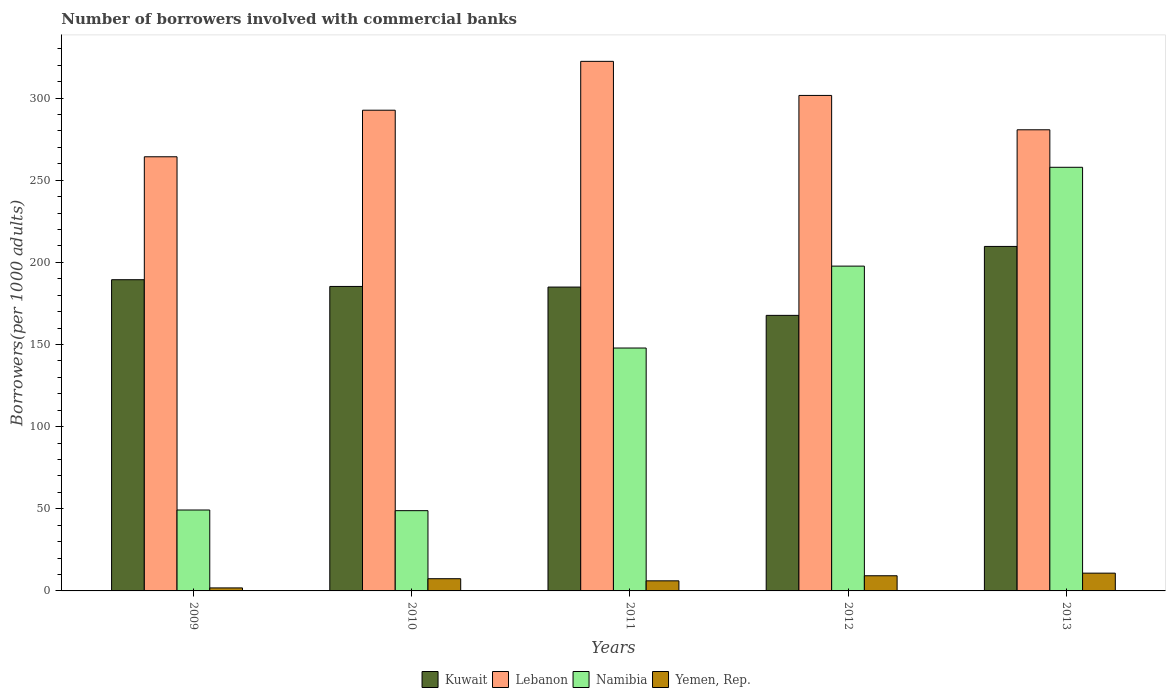How many different coloured bars are there?
Offer a terse response. 4. How many groups of bars are there?
Your answer should be very brief. 5. Are the number of bars per tick equal to the number of legend labels?
Provide a succinct answer. Yes. Are the number of bars on each tick of the X-axis equal?
Your response must be concise. Yes. What is the number of borrowers involved with commercial banks in Lebanon in 2010?
Provide a succinct answer. 292.58. Across all years, what is the maximum number of borrowers involved with commercial banks in Yemen, Rep.?
Your response must be concise. 10.82. Across all years, what is the minimum number of borrowers involved with commercial banks in Kuwait?
Your answer should be very brief. 167.71. In which year was the number of borrowers involved with commercial banks in Namibia maximum?
Your answer should be compact. 2013. In which year was the number of borrowers involved with commercial banks in Kuwait minimum?
Offer a very short reply. 2012. What is the total number of borrowers involved with commercial banks in Kuwait in the graph?
Ensure brevity in your answer.  937.07. What is the difference between the number of borrowers involved with commercial banks in Kuwait in 2009 and that in 2013?
Your response must be concise. -20.26. What is the difference between the number of borrowers involved with commercial banks in Kuwait in 2011 and the number of borrowers involved with commercial banks in Lebanon in 2009?
Offer a terse response. -79.3. What is the average number of borrowers involved with commercial banks in Lebanon per year?
Make the answer very short. 292.28. In the year 2010, what is the difference between the number of borrowers involved with commercial banks in Kuwait and number of borrowers involved with commercial banks in Yemen, Rep.?
Keep it short and to the point. 177.89. What is the ratio of the number of borrowers involved with commercial banks in Kuwait in 2009 to that in 2010?
Your response must be concise. 1.02. Is the difference between the number of borrowers involved with commercial banks in Kuwait in 2009 and 2010 greater than the difference between the number of borrowers involved with commercial banks in Yemen, Rep. in 2009 and 2010?
Your answer should be very brief. Yes. What is the difference between the highest and the second highest number of borrowers involved with commercial banks in Lebanon?
Ensure brevity in your answer.  20.74. What is the difference between the highest and the lowest number of borrowers involved with commercial banks in Kuwait?
Your answer should be very brief. 41.96. In how many years, is the number of borrowers involved with commercial banks in Yemen, Rep. greater than the average number of borrowers involved with commercial banks in Yemen, Rep. taken over all years?
Keep it short and to the point. 3. What does the 1st bar from the left in 2009 represents?
Ensure brevity in your answer.  Kuwait. What does the 3rd bar from the right in 2012 represents?
Keep it short and to the point. Lebanon. Are all the bars in the graph horizontal?
Your response must be concise. No. Where does the legend appear in the graph?
Offer a very short reply. Bottom center. What is the title of the graph?
Your answer should be compact. Number of borrowers involved with commercial banks. Does "Romania" appear as one of the legend labels in the graph?
Make the answer very short. No. What is the label or title of the X-axis?
Ensure brevity in your answer.  Years. What is the label or title of the Y-axis?
Offer a very short reply. Borrowers(per 1000 adults). What is the Borrowers(per 1000 adults) in Kuwait in 2009?
Provide a succinct answer. 189.42. What is the Borrowers(per 1000 adults) in Lebanon in 2009?
Ensure brevity in your answer.  264.25. What is the Borrowers(per 1000 adults) in Namibia in 2009?
Your answer should be very brief. 49.25. What is the Borrowers(per 1000 adults) of Yemen, Rep. in 2009?
Your answer should be very brief. 1.83. What is the Borrowers(per 1000 adults) of Kuwait in 2010?
Your response must be concise. 185.32. What is the Borrowers(per 1000 adults) of Lebanon in 2010?
Offer a very short reply. 292.58. What is the Borrowers(per 1000 adults) of Namibia in 2010?
Your answer should be compact. 48.85. What is the Borrowers(per 1000 adults) in Yemen, Rep. in 2010?
Your response must be concise. 7.43. What is the Borrowers(per 1000 adults) in Kuwait in 2011?
Offer a very short reply. 184.94. What is the Borrowers(per 1000 adults) of Lebanon in 2011?
Provide a succinct answer. 322.32. What is the Borrowers(per 1000 adults) of Namibia in 2011?
Ensure brevity in your answer.  147.84. What is the Borrowers(per 1000 adults) in Yemen, Rep. in 2011?
Offer a very short reply. 6.14. What is the Borrowers(per 1000 adults) of Kuwait in 2012?
Give a very brief answer. 167.71. What is the Borrowers(per 1000 adults) in Lebanon in 2012?
Offer a very short reply. 301.58. What is the Borrowers(per 1000 adults) in Namibia in 2012?
Provide a short and direct response. 197.69. What is the Borrowers(per 1000 adults) in Yemen, Rep. in 2012?
Your answer should be very brief. 9.23. What is the Borrowers(per 1000 adults) of Kuwait in 2013?
Keep it short and to the point. 209.68. What is the Borrowers(per 1000 adults) of Lebanon in 2013?
Offer a very short reply. 280.67. What is the Borrowers(per 1000 adults) of Namibia in 2013?
Your answer should be compact. 257.84. What is the Borrowers(per 1000 adults) in Yemen, Rep. in 2013?
Make the answer very short. 10.82. Across all years, what is the maximum Borrowers(per 1000 adults) of Kuwait?
Your response must be concise. 209.68. Across all years, what is the maximum Borrowers(per 1000 adults) of Lebanon?
Offer a very short reply. 322.32. Across all years, what is the maximum Borrowers(per 1000 adults) of Namibia?
Make the answer very short. 257.84. Across all years, what is the maximum Borrowers(per 1000 adults) in Yemen, Rep.?
Your response must be concise. 10.82. Across all years, what is the minimum Borrowers(per 1000 adults) of Kuwait?
Your answer should be compact. 167.71. Across all years, what is the minimum Borrowers(per 1000 adults) in Lebanon?
Your response must be concise. 264.25. Across all years, what is the minimum Borrowers(per 1000 adults) of Namibia?
Keep it short and to the point. 48.85. Across all years, what is the minimum Borrowers(per 1000 adults) of Yemen, Rep.?
Give a very brief answer. 1.83. What is the total Borrowers(per 1000 adults) in Kuwait in the graph?
Your answer should be very brief. 937.07. What is the total Borrowers(per 1000 adults) of Lebanon in the graph?
Provide a succinct answer. 1461.39. What is the total Borrowers(per 1000 adults) of Namibia in the graph?
Give a very brief answer. 701.47. What is the total Borrowers(per 1000 adults) of Yemen, Rep. in the graph?
Your answer should be compact. 35.45. What is the difference between the Borrowers(per 1000 adults) in Kuwait in 2009 and that in 2010?
Give a very brief answer. 4.09. What is the difference between the Borrowers(per 1000 adults) of Lebanon in 2009 and that in 2010?
Ensure brevity in your answer.  -28.33. What is the difference between the Borrowers(per 1000 adults) in Namibia in 2009 and that in 2010?
Offer a terse response. 0.4. What is the difference between the Borrowers(per 1000 adults) in Yemen, Rep. in 2009 and that in 2010?
Give a very brief answer. -5.6. What is the difference between the Borrowers(per 1000 adults) in Kuwait in 2009 and that in 2011?
Your response must be concise. 4.47. What is the difference between the Borrowers(per 1000 adults) in Lebanon in 2009 and that in 2011?
Your answer should be compact. -58.07. What is the difference between the Borrowers(per 1000 adults) in Namibia in 2009 and that in 2011?
Keep it short and to the point. -98.59. What is the difference between the Borrowers(per 1000 adults) in Yemen, Rep. in 2009 and that in 2011?
Your response must be concise. -4.32. What is the difference between the Borrowers(per 1000 adults) in Kuwait in 2009 and that in 2012?
Keep it short and to the point. 21.7. What is the difference between the Borrowers(per 1000 adults) in Lebanon in 2009 and that in 2012?
Provide a short and direct response. -37.33. What is the difference between the Borrowers(per 1000 adults) in Namibia in 2009 and that in 2012?
Make the answer very short. -148.44. What is the difference between the Borrowers(per 1000 adults) in Yemen, Rep. in 2009 and that in 2012?
Your answer should be compact. -7.41. What is the difference between the Borrowers(per 1000 adults) in Kuwait in 2009 and that in 2013?
Your answer should be very brief. -20.26. What is the difference between the Borrowers(per 1000 adults) in Lebanon in 2009 and that in 2013?
Make the answer very short. -16.42. What is the difference between the Borrowers(per 1000 adults) of Namibia in 2009 and that in 2013?
Your answer should be very brief. -208.59. What is the difference between the Borrowers(per 1000 adults) of Yemen, Rep. in 2009 and that in 2013?
Offer a very short reply. -8.99. What is the difference between the Borrowers(per 1000 adults) in Kuwait in 2010 and that in 2011?
Your response must be concise. 0.38. What is the difference between the Borrowers(per 1000 adults) in Lebanon in 2010 and that in 2011?
Provide a succinct answer. -29.74. What is the difference between the Borrowers(per 1000 adults) of Namibia in 2010 and that in 2011?
Offer a very short reply. -99. What is the difference between the Borrowers(per 1000 adults) of Yemen, Rep. in 2010 and that in 2011?
Provide a succinct answer. 1.29. What is the difference between the Borrowers(per 1000 adults) in Kuwait in 2010 and that in 2012?
Your answer should be very brief. 17.61. What is the difference between the Borrowers(per 1000 adults) of Lebanon in 2010 and that in 2012?
Give a very brief answer. -9. What is the difference between the Borrowers(per 1000 adults) of Namibia in 2010 and that in 2012?
Provide a short and direct response. -148.84. What is the difference between the Borrowers(per 1000 adults) of Yemen, Rep. in 2010 and that in 2012?
Keep it short and to the point. -1.8. What is the difference between the Borrowers(per 1000 adults) of Kuwait in 2010 and that in 2013?
Your answer should be compact. -24.35. What is the difference between the Borrowers(per 1000 adults) of Lebanon in 2010 and that in 2013?
Provide a short and direct response. 11.91. What is the difference between the Borrowers(per 1000 adults) in Namibia in 2010 and that in 2013?
Ensure brevity in your answer.  -208.99. What is the difference between the Borrowers(per 1000 adults) in Yemen, Rep. in 2010 and that in 2013?
Provide a succinct answer. -3.39. What is the difference between the Borrowers(per 1000 adults) of Kuwait in 2011 and that in 2012?
Your answer should be very brief. 17.23. What is the difference between the Borrowers(per 1000 adults) in Lebanon in 2011 and that in 2012?
Ensure brevity in your answer.  20.74. What is the difference between the Borrowers(per 1000 adults) in Namibia in 2011 and that in 2012?
Give a very brief answer. -49.85. What is the difference between the Borrowers(per 1000 adults) in Yemen, Rep. in 2011 and that in 2012?
Your answer should be compact. -3.09. What is the difference between the Borrowers(per 1000 adults) of Kuwait in 2011 and that in 2013?
Offer a terse response. -24.73. What is the difference between the Borrowers(per 1000 adults) of Lebanon in 2011 and that in 2013?
Make the answer very short. 41.65. What is the difference between the Borrowers(per 1000 adults) in Namibia in 2011 and that in 2013?
Your response must be concise. -110. What is the difference between the Borrowers(per 1000 adults) of Yemen, Rep. in 2011 and that in 2013?
Offer a terse response. -4.67. What is the difference between the Borrowers(per 1000 adults) in Kuwait in 2012 and that in 2013?
Ensure brevity in your answer.  -41.96. What is the difference between the Borrowers(per 1000 adults) of Lebanon in 2012 and that in 2013?
Your answer should be very brief. 20.91. What is the difference between the Borrowers(per 1000 adults) of Namibia in 2012 and that in 2013?
Your answer should be compact. -60.15. What is the difference between the Borrowers(per 1000 adults) in Yemen, Rep. in 2012 and that in 2013?
Your response must be concise. -1.58. What is the difference between the Borrowers(per 1000 adults) in Kuwait in 2009 and the Borrowers(per 1000 adults) in Lebanon in 2010?
Ensure brevity in your answer.  -103.17. What is the difference between the Borrowers(per 1000 adults) in Kuwait in 2009 and the Borrowers(per 1000 adults) in Namibia in 2010?
Provide a succinct answer. 140.57. What is the difference between the Borrowers(per 1000 adults) of Kuwait in 2009 and the Borrowers(per 1000 adults) of Yemen, Rep. in 2010?
Give a very brief answer. 181.99. What is the difference between the Borrowers(per 1000 adults) in Lebanon in 2009 and the Borrowers(per 1000 adults) in Namibia in 2010?
Provide a short and direct response. 215.4. What is the difference between the Borrowers(per 1000 adults) in Lebanon in 2009 and the Borrowers(per 1000 adults) in Yemen, Rep. in 2010?
Your answer should be compact. 256.82. What is the difference between the Borrowers(per 1000 adults) in Namibia in 2009 and the Borrowers(per 1000 adults) in Yemen, Rep. in 2010?
Provide a succinct answer. 41.82. What is the difference between the Borrowers(per 1000 adults) in Kuwait in 2009 and the Borrowers(per 1000 adults) in Lebanon in 2011?
Give a very brief answer. -132.9. What is the difference between the Borrowers(per 1000 adults) in Kuwait in 2009 and the Borrowers(per 1000 adults) in Namibia in 2011?
Your answer should be very brief. 41.57. What is the difference between the Borrowers(per 1000 adults) in Kuwait in 2009 and the Borrowers(per 1000 adults) in Yemen, Rep. in 2011?
Your answer should be very brief. 183.27. What is the difference between the Borrowers(per 1000 adults) of Lebanon in 2009 and the Borrowers(per 1000 adults) of Namibia in 2011?
Your answer should be compact. 116.4. What is the difference between the Borrowers(per 1000 adults) in Lebanon in 2009 and the Borrowers(per 1000 adults) in Yemen, Rep. in 2011?
Offer a terse response. 258.1. What is the difference between the Borrowers(per 1000 adults) in Namibia in 2009 and the Borrowers(per 1000 adults) in Yemen, Rep. in 2011?
Your answer should be compact. 43.11. What is the difference between the Borrowers(per 1000 adults) in Kuwait in 2009 and the Borrowers(per 1000 adults) in Lebanon in 2012?
Give a very brief answer. -112.16. What is the difference between the Borrowers(per 1000 adults) in Kuwait in 2009 and the Borrowers(per 1000 adults) in Namibia in 2012?
Keep it short and to the point. -8.27. What is the difference between the Borrowers(per 1000 adults) of Kuwait in 2009 and the Borrowers(per 1000 adults) of Yemen, Rep. in 2012?
Provide a short and direct response. 180.18. What is the difference between the Borrowers(per 1000 adults) in Lebanon in 2009 and the Borrowers(per 1000 adults) in Namibia in 2012?
Provide a succinct answer. 66.56. What is the difference between the Borrowers(per 1000 adults) of Lebanon in 2009 and the Borrowers(per 1000 adults) of Yemen, Rep. in 2012?
Your answer should be compact. 255.01. What is the difference between the Borrowers(per 1000 adults) in Namibia in 2009 and the Borrowers(per 1000 adults) in Yemen, Rep. in 2012?
Provide a succinct answer. 40.02. What is the difference between the Borrowers(per 1000 adults) of Kuwait in 2009 and the Borrowers(per 1000 adults) of Lebanon in 2013?
Ensure brevity in your answer.  -91.25. What is the difference between the Borrowers(per 1000 adults) of Kuwait in 2009 and the Borrowers(per 1000 adults) of Namibia in 2013?
Provide a short and direct response. -68.43. What is the difference between the Borrowers(per 1000 adults) in Kuwait in 2009 and the Borrowers(per 1000 adults) in Yemen, Rep. in 2013?
Provide a succinct answer. 178.6. What is the difference between the Borrowers(per 1000 adults) of Lebanon in 2009 and the Borrowers(per 1000 adults) of Namibia in 2013?
Give a very brief answer. 6.41. What is the difference between the Borrowers(per 1000 adults) in Lebanon in 2009 and the Borrowers(per 1000 adults) in Yemen, Rep. in 2013?
Provide a succinct answer. 253.43. What is the difference between the Borrowers(per 1000 adults) in Namibia in 2009 and the Borrowers(per 1000 adults) in Yemen, Rep. in 2013?
Make the answer very short. 38.43. What is the difference between the Borrowers(per 1000 adults) of Kuwait in 2010 and the Borrowers(per 1000 adults) of Lebanon in 2011?
Provide a succinct answer. -137. What is the difference between the Borrowers(per 1000 adults) in Kuwait in 2010 and the Borrowers(per 1000 adults) in Namibia in 2011?
Your answer should be compact. 37.48. What is the difference between the Borrowers(per 1000 adults) of Kuwait in 2010 and the Borrowers(per 1000 adults) of Yemen, Rep. in 2011?
Provide a succinct answer. 179.18. What is the difference between the Borrowers(per 1000 adults) of Lebanon in 2010 and the Borrowers(per 1000 adults) of Namibia in 2011?
Make the answer very short. 144.74. What is the difference between the Borrowers(per 1000 adults) of Lebanon in 2010 and the Borrowers(per 1000 adults) of Yemen, Rep. in 2011?
Offer a very short reply. 286.44. What is the difference between the Borrowers(per 1000 adults) of Namibia in 2010 and the Borrowers(per 1000 adults) of Yemen, Rep. in 2011?
Give a very brief answer. 42.7. What is the difference between the Borrowers(per 1000 adults) of Kuwait in 2010 and the Borrowers(per 1000 adults) of Lebanon in 2012?
Provide a succinct answer. -116.26. What is the difference between the Borrowers(per 1000 adults) in Kuwait in 2010 and the Borrowers(per 1000 adults) in Namibia in 2012?
Offer a very short reply. -12.37. What is the difference between the Borrowers(per 1000 adults) in Kuwait in 2010 and the Borrowers(per 1000 adults) in Yemen, Rep. in 2012?
Offer a very short reply. 176.09. What is the difference between the Borrowers(per 1000 adults) in Lebanon in 2010 and the Borrowers(per 1000 adults) in Namibia in 2012?
Provide a succinct answer. 94.89. What is the difference between the Borrowers(per 1000 adults) in Lebanon in 2010 and the Borrowers(per 1000 adults) in Yemen, Rep. in 2012?
Your response must be concise. 283.35. What is the difference between the Borrowers(per 1000 adults) in Namibia in 2010 and the Borrowers(per 1000 adults) in Yemen, Rep. in 2012?
Offer a very short reply. 39.61. What is the difference between the Borrowers(per 1000 adults) of Kuwait in 2010 and the Borrowers(per 1000 adults) of Lebanon in 2013?
Your answer should be compact. -95.35. What is the difference between the Borrowers(per 1000 adults) in Kuwait in 2010 and the Borrowers(per 1000 adults) in Namibia in 2013?
Provide a succinct answer. -72.52. What is the difference between the Borrowers(per 1000 adults) of Kuwait in 2010 and the Borrowers(per 1000 adults) of Yemen, Rep. in 2013?
Offer a very short reply. 174.5. What is the difference between the Borrowers(per 1000 adults) of Lebanon in 2010 and the Borrowers(per 1000 adults) of Namibia in 2013?
Ensure brevity in your answer.  34.74. What is the difference between the Borrowers(per 1000 adults) in Lebanon in 2010 and the Borrowers(per 1000 adults) in Yemen, Rep. in 2013?
Keep it short and to the point. 281.76. What is the difference between the Borrowers(per 1000 adults) of Namibia in 2010 and the Borrowers(per 1000 adults) of Yemen, Rep. in 2013?
Your answer should be very brief. 38.03. What is the difference between the Borrowers(per 1000 adults) in Kuwait in 2011 and the Borrowers(per 1000 adults) in Lebanon in 2012?
Give a very brief answer. -116.63. What is the difference between the Borrowers(per 1000 adults) of Kuwait in 2011 and the Borrowers(per 1000 adults) of Namibia in 2012?
Your response must be concise. -12.75. What is the difference between the Borrowers(per 1000 adults) of Kuwait in 2011 and the Borrowers(per 1000 adults) of Yemen, Rep. in 2012?
Your answer should be compact. 175.71. What is the difference between the Borrowers(per 1000 adults) of Lebanon in 2011 and the Borrowers(per 1000 adults) of Namibia in 2012?
Give a very brief answer. 124.63. What is the difference between the Borrowers(per 1000 adults) in Lebanon in 2011 and the Borrowers(per 1000 adults) in Yemen, Rep. in 2012?
Your answer should be very brief. 313.09. What is the difference between the Borrowers(per 1000 adults) in Namibia in 2011 and the Borrowers(per 1000 adults) in Yemen, Rep. in 2012?
Your answer should be very brief. 138.61. What is the difference between the Borrowers(per 1000 adults) in Kuwait in 2011 and the Borrowers(per 1000 adults) in Lebanon in 2013?
Provide a short and direct response. -95.72. What is the difference between the Borrowers(per 1000 adults) in Kuwait in 2011 and the Borrowers(per 1000 adults) in Namibia in 2013?
Provide a short and direct response. -72.9. What is the difference between the Borrowers(per 1000 adults) of Kuwait in 2011 and the Borrowers(per 1000 adults) of Yemen, Rep. in 2013?
Give a very brief answer. 174.13. What is the difference between the Borrowers(per 1000 adults) in Lebanon in 2011 and the Borrowers(per 1000 adults) in Namibia in 2013?
Your answer should be very brief. 64.48. What is the difference between the Borrowers(per 1000 adults) in Lebanon in 2011 and the Borrowers(per 1000 adults) in Yemen, Rep. in 2013?
Your answer should be compact. 311.5. What is the difference between the Borrowers(per 1000 adults) in Namibia in 2011 and the Borrowers(per 1000 adults) in Yemen, Rep. in 2013?
Make the answer very short. 137.03. What is the difference between the Borrowers(per 1000 adults) in Kuwait in 2012 and the Borrowers(per 1000 adults) in Lebanon in 2013?
Offer a terse response. -112.95. What is the difference between the Borrowers(per 1000 adults) of Kuwait in 2012 and the Borrowers(per 1000 adults) of Namibia in 2013?
Provide a succinct answer. -90.13. What is the difference between the Borrowers(per 1000 adults) of Kuwait in 2012 and the Borrowers(per 1000 adults) of Yemen, Rep. in 2013?
Offer a terse response. 156.9. What is the difference between the Borrowers(per 1000 adults) in Lebanon in 2012 and the Borrowers(per 1000 adults) in Namibia in 2013?
Your answer should be very brief. 43.74. What is the difference between the Borrowers(per 1000 adults) in Lebanon in 2012 and the Borrowers(per 1000 adults) in Yemen, Rep. in 2013?
Offer a terse response. 290.76. What is the difference between the Borrowers(per 1000 adults) of Namibia in 2012 and the Borrowers(per 1000 adults) of Yemen, Rep. in 2013?
Provide a short and direct response. 186.87. What is the average Borrowers(per 1000 adults) in Kuwait per year?
Give a very brief answer. 187.41. What is the average Borrowers(per 1000 adults) in Lebanon per year?
Keep it short and to the point. 292.28. What is the average Borrowers(per 1000 adults) in Namibia per year?
Your response must be concise. 140.29. What is the average Borrowers(per 1000 adults) of Yemen, Rep. per year?
Provide a succinct answer. 7.09. In the year 2009, what is the difference between the Borrowers(per 1000 adults) of Kuwait and Borrowers(per 1000 adults) of Lebanon?
Your answer should be very brief. -74.83. In the year 2009, what is the difference between the Borrowers(per 1000 adults) of Kuwait and Borrowers(per 1000 adults) of Namibia?
Your answer should be very brief. 140.17. In the year 2009, what is the difference between the Borrowers(per 1000 adults) in Kuwait and Borrowers(per 1000 adults) in Yemen, Rep.?
Your answer should be compact. 187.59. In the year 2009, what is the difference between the Borrowers(per 1000 adults) in Lebanon and Borrowers(per 1000 adults) in Namibia?
Make the answer very short. 215. In the year 2009, what is the difference between the Borrowers(per 1000 adults) of Lebanon and Borrowers(per 1000 adults) of Yemen, Rep.?
Keep it short and to the point. 262.42. In the year 2009, what is the difference between the Borrowers(per 1000 adults) of Namibia and Borrowers(per 1000 adults) of Yemen, Rep.?
Your response must be concise. 47.42. In the year 2010, what is the difference between the Borrowers(per 1000 adults) of Kuwait and Borrowers(per 1000 adults) of Lebanon?
Offer a very short reply. -107.26. In the year 2010, what is the difference between the Borrowers(per 1000 adults) in Kuwait and Borrowers(per 1000 adults) in Namibia?
Ensure brevity in your answer.  136.47. In the year 2010, what is the difference between the Borrowers(per 1000 adults) of Kuwait and Borrowers(per 1000 adults) of Yemen, Rep.?
Keep it short and to the point. 177.89. In the year 2010, what is the difference between the Borrowers(per 1000 adults) of Lebanon and Borrowers(per 1000 adults) of Namibia?
Make the answer very short. 243.73. In the year 2010, what is the difference between the Borrowers(per 1000 adults) of Lebanon and Borrowers(per 1000 adults) of Yemen, Rep.?
Your response must be concise. 285.15. In the year 2010, what is the difference between the Borrowers(per 1000 adults) in Namibia and Borrowers(per 1000 adults) in Yemen, Rep.?
Your response must be concise. 41.42. In the year 2011, what is the difference between the Borrowers(per 1000 adults) of Kuwait and Borrowers(per 1000 adults) of Lebanon?
Your answer should be very brief. -137.38. In the year 2011, what is the difference between the Borrowers(per 1000 adults) in Kuwait and Borrowers(per 1000 adults) in Namibia?
Ensure brevity in your answer.  37.1. In the year 2011, what is the difference between the Borrowers(per 1000 adults) in Kuwait and Borrowers(per 1000 adults) in Yemen, Rep.?
Your answer should be compact. 178.8. In the year 2011, what is the difference between the Borrowers(per 1000 adults) of Lebanon and Borrowers(per 1000 adults) of Namibia?
Offer a very short reply. 174.48. In the year 2011, what is the difference between the Borrowers(per 1000 adults) in Lebanon and Borrowers(per 1000 adults) in Yemen, Rep.?
Give a very brief answer. 316.18. In the year 2011, what is the difference between the Borrowers(per 1000 adults) of Namibia and Borrowers(per 1000 adults) of Yemen, Rep.?
Offer a terse response. 141.7. In the year 2012, what is the difference between the Borrowers(per 1000 adults) in Kuwait and Borrowers(per 1000 adults) in Lebanon?
Your answer should be very brief. -133.86. In the year 2012, what is the difference between the Borrowers(per 1000 adults) of Kuwait and Borrowers(per 1000 adults) of Namibia?
Your response must be concise. -29.98. In the year 2012, what is the difference between the Borrowers(per 1000 adults) of Kuwait and Borrowers(per 1000 adults) of Yemen, Rep.?
Make the answer very short. 158.48. In the year 2012, what is the difference between the Borrowers(per 1000 adults) in Lebanon and Borrowers(per 1000 adults) in Namibia?
Offer a very short reply. 103.89. In the year 2012, what is the difference between the Borrowers(per 1000 adults) of Lebanon and Borrowers(per 1000 adults) of Yemen, Rep.?
Give a very brief answer. 292.34. In the year 2012, what is the difference between the Borrowers(per 1000 adults) of Namibia and Borrowers(per 1000 adults) of Yemen, Rep.?
Offer a terse response. 188.46. In the year 2013, what is the difference between the Borrowers(per 1000 adults) in Kuwait and Borrowers(per 1000 adults) in Lebanon?
Your response must be concise. -70.99. In the year 2013, what is the difference between the Borrowers(per 1000 adults) of Kuwait and Borrowers(per 1000 adults) of Namibia?
Offer a very short reply. -48.17. In the year 2013, what is the difference between the Borrowers(per 1000 adults) of Kuwait and Borrowers(per 1000 adults) of Yemen, Rep.?
Your response must be concise. 198.86. In the year 2013, what is the difference between the Borrowers(per 1000 adults) of Lebanon and Borrowers(per 1000 adults) of Namibia?
Your answer should be very brief. 22.82. In the year 2013, what is the difference between the Borrowers(per 1000 adults) of Lebanon and Borrowers(per 1000 adults) of Yemen, Rep.?
Your answer should be compact. 269.85. In the year 2013, what is the difference between the Borrowers(per 1000 adults) of Namibia and Borrowers(per 1000 adults) of Yemen, Rep.?
Your answer should be compact. 247.03. What is the ratio of the Borrowers(per 1000 adults) in Kuwait in 2009 to that in 2010?
Offer a very short reply. 1.02. What is the ratio of the Borrowers(per 1000 adults) in Lebanon in 2009 to that in 2010?
Ensure brevity in your answer.  0.9. What is the ratio of the Borrowers(per 1000 adults) of Namibia in 2009 to that in 2010?
Provide a succinct answer. 1.01. What is the ratio of the Borrowers(per 1000 adults) in Yemen, Rep. in 2009 to that in 2010?
Give a very brief answer. 0.25. What is the ratio of the Borrowers(per 1000 adults) of Kuwait in 2009 to that in 2011?
Make the answer very short. 1.02. What is the ratio of the Borrowers(per 1000 adults) in Lebanon in 2009 to that in 2011?
Your answer should be compact. 0.82. What is the ratio of the Borrowers(per 1000 adults) of Namibia in 2009 to that in 2011?
Offer a very short reply. 0.33. What is the ratio of the Borrowers(per 1000 adults) in Yemen, Rep. in 2009 to that in 2011?
Offer a very short reply. 0.3. What is the ratio of the Borrowers(per 1000 adults) of Kuwait in 2009 to that in 2012?
Your answer should be compact. 1.13. What is the ratio of the Borrowers(per 1000 adults) in Lebanon in 2009 to that in 2012?
Offer a terse response. 0.88. What is the ratio of the Borrowers(per 1000 adults) of Namibia in 2009 to that in 2012?
Give a very brief answer. 0.25. What is the ratio of the Borrowers(per 1000 adults) of Yemen, Rep. in 2009 to that in 2012?
Keep it short and to the point. 0.2. What is the ratio of the Borrowers(per 1000 adults) of Kuwait in 2009 to that in 2013?
Offer a terse response. 0.9. What is the ratio of the Borrowers(per 1000 adults) of Lebanon in 2009 to that in 2013?
Your answer should be compact. 0.94. What is the ratio of the Borrowers(per 1000 adults) of Namibia in 2009 to that in 2013?
Offer a very short reply. 0.19. What is the ratio of the Borrowers(per 1000 adults) of Yemen, Rep. in 2009 to that in 2013?
Your response must be concise. 0.17. What is the ratio of the Borrowers(per 1000 adults) of Kuwait in 2010 to that in 2011?
Offer a terse response. 1. What is the ratio of the Borrowers(per 1000 adults) of Lebanon in 2010 to that in 2011?
Provide a succinct answer. 0.91. What is the ratio of the Borrowers(per 1000 adults) of Namibia in 2010 to that in 2011?
Give a very brief answer. 0.33. What is the ratio of the Borrowers(per 1000 adults) in Yemen, Rep. in 2010 to that in 2011?
Give a very brief answer. 1.21. What is the ratio of the Borrowers(per 1000 adults) of Kuwait in 2010 to that in 2012?
Give a very brief answer. 1.1. What is the ratio of the Borrowers(per 1000 adults) of Lebanon in 2010 to that in 2012?
Your answer should be compact. 0.97. What is the ratio of the Borrowers(per 1000 adults) of Namibia in 2010 to that in 2012?
Your response must be concise. 0.25. What is the ratio of the Borrowers(per 1000 adults) in Yemen, Rep. in 2010 to that in 2012?
Provide a succinct answer. 0.8. What is the ratio of the Borrowers(per 1000 adults) of Kuwait in 2010 to that in 2013?
Your answer should be very brief. 0.88. What is the ratio of the Borrowers(per 1000 adults) in Lebanon in 2010 to that in 2013?
Provide a succinct answer. 1.04. What is the ratio of the Borrowers(per 1000 adults) of Namibia in 2010 to that in 2013?
Offer a very short reply. 0.19. What is the ratio of the Borrowers(per 1000 adults) in Yemen, Rep. in 2010 to that in 2013?
Your response must be concise. 0.69. What is the ratio of the Borrowers(per 1000 adults) of Kuwait in 2011 to that in 2012?
Your answer should be very brief. 1.1. What is the ratio of the Borrowers(per 1000 adults) in Lebanon in 2011 to that in 2012?
Give a very brief answer. 1.07. What is the ratio of the Borrowers(per 1000 adults) of Namibia in 2011 to that in 2012?
Offer a very short reply. 0.75. What is the ratio of the Borrowers(per 1000 adults) in Yemen, Rep. in 2011 to that in 2012?
Ensure brevity in your answer.  0.67. What is the ratio of the Borrowers(per 1000 adults) in Kuwait in 2011 to that in 2013?
Offer a very short reply. 0.88. What is the ratio of the Borrowers(per 1000 adults) in Lebanon in 2011 to that in 2013?
Ensure brevity in your answer.  1.15. What is the ratio of the Borrowers(per 1000 adults) of Namibia in 2011 to that in 2013?
Your response must be concise. 0.57. What is the ratio of the Borrowers(per 1000 adults) of Yemen, Rep. in 2011 to that in 2013?
Keep it short and to the point. 0.57. What is the ratio of the Borrowers(per 1000 adults) in Kuwait in 2012 to that in 2013?
Ensure brevity in your answer.  0.8. What is the ratio of the Borrowers(per 1000 adults) of Lebanon in 2012 to that in 2013?
Keep it short and to the point. 1.07. What is the ratio of the Borrowers(per 1000 adults) in Namibia in 2012 to that in 2013?
Give a very brief answer. 0.77. What is the ratio of the Borrowers(per 1000 adults) in Yemen, Rep. in 2012 to that in 2013?
Offer a very short reply. 0.85. What is the difference between the highest and the second highest Borrowers(per 1000 adults) in Kuwait?
Your answer should be compact. 20.26. What is the difference between the highest and the second highest Borrowers(per 1000 adults) in Lebanon?
Offer a terse response. 20.74. What is the difference between the highest and the second highest Borrowers(per 1000 adults) of Namibia?
Give a very brief answer. 60.15. What is the difference between the highest and the second highest Borrowers(per 1000 adults) in Yemen, Rep.?
Ensure brevity in your answer.  1.58. What is the difference between the highest and the lowest Borrowers(per 1000 adults) in Kuwait?
Ensure brevity in your answer.  41.96. What is the difference between the highest and the lowest Borrowers(per 1000 adults) of Lebanon?
Your answer should be compact. 58.07. What is the difference between the highest and the lowest Borrowers(per 1000 adults) of Namibia?
Ensure brevity in your answer.  208.99. What is the difference between the highest and the lowest Borrowers(per 1000 adults) of Yemen, Rep.?
Ensure brevity in your answer.  8.99. 